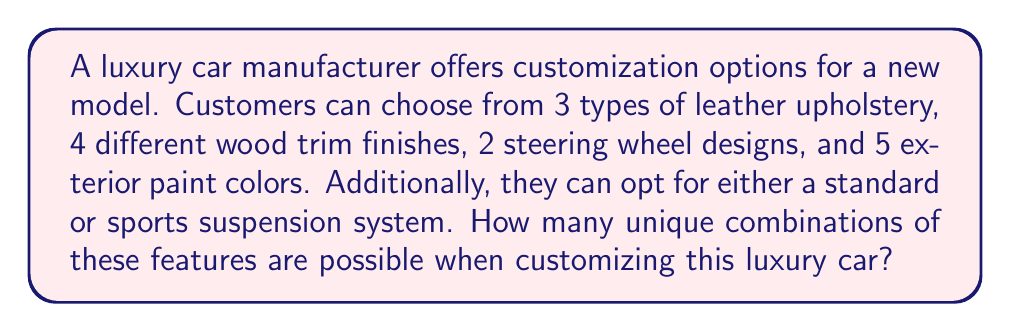Can you solve this math problem? Let's break this down step-by-step:

1) We have 5 different categories of options:
   - Leather upholstery: 3 choices
   - Wood trim finishes: 4 choices
   - Steering wheel designs: 2 choices
   - Exterior paint colors: 5 choices
   - Suspension system: 2 choices (standard or sports)

2) For each category, the customer must choose exactly one option.

3) The choices in each category are independent of the choices in other categories.

4) This scenario fits the multiplication principle of counting. When we have a sequence of independent choices, we multiply the number of options for each choice.

5) Therefore, the total number of unique combinations is:

   $$ 3 \times 4 \times 2 \times 5 \times 2 $$

6) Let's calculate:
   $$ 3 \times 4 \times 2 \times 5 \times 2 = 240 $$

Thus, there are 240 unique ways to customize this luxury car with the given options.
Answer: 240 